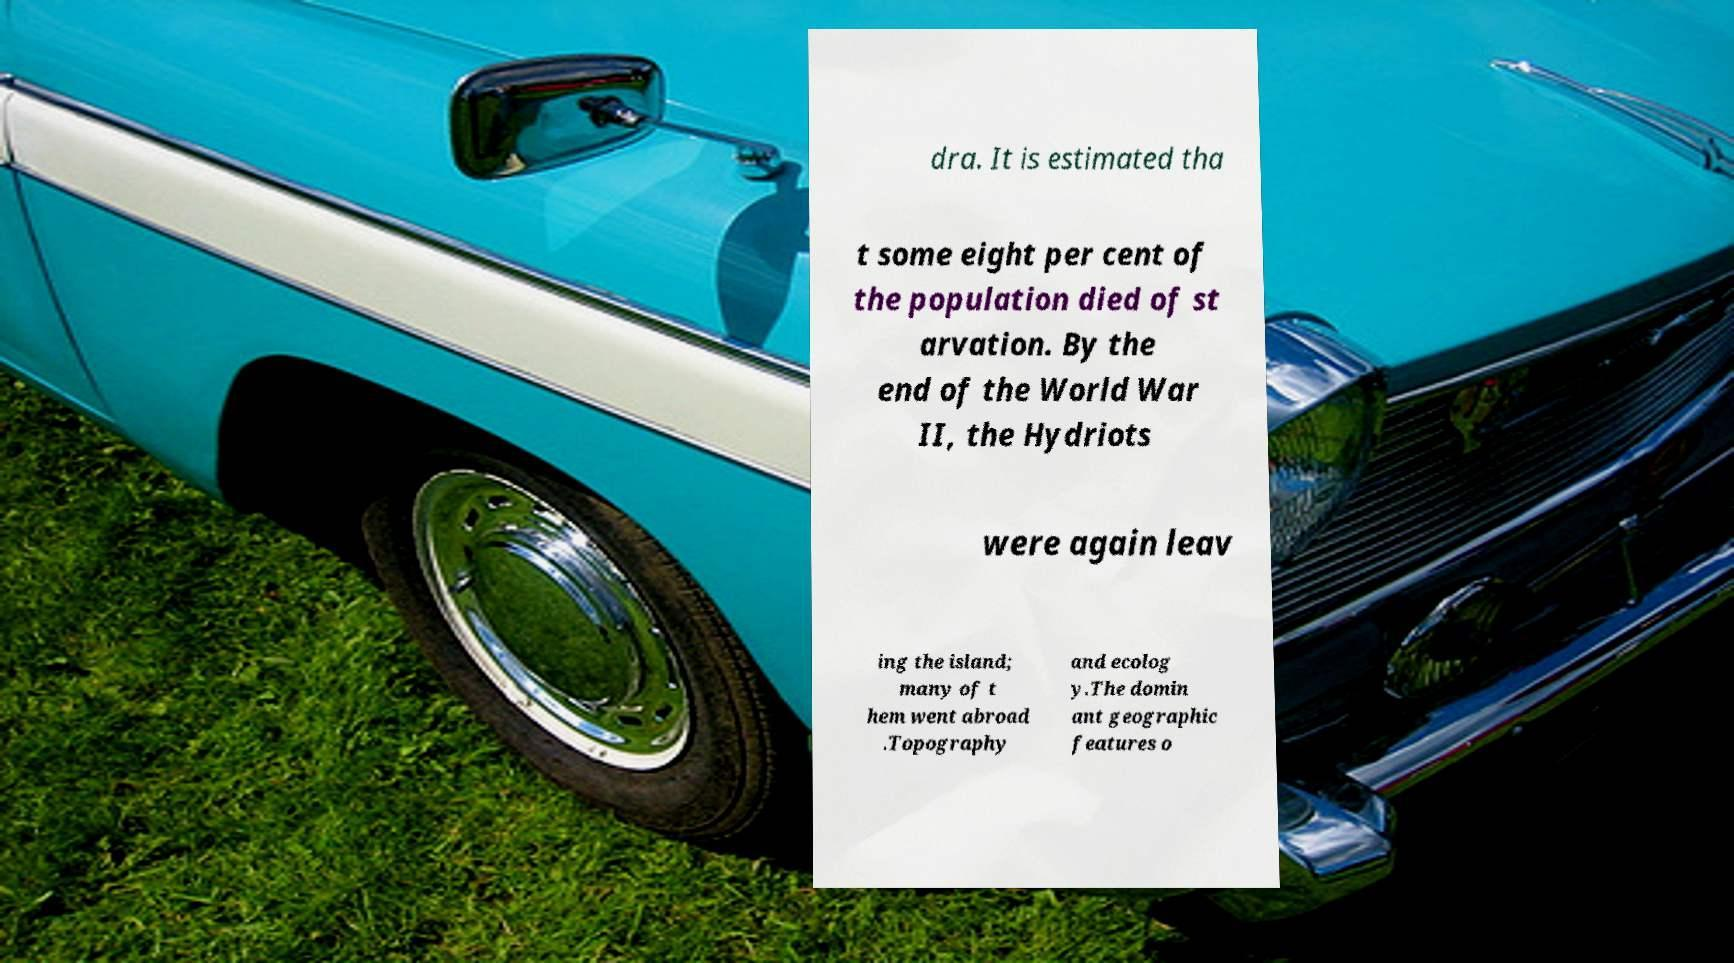Could you extract and type out the text from this image? dra. It is estimated tha t some eight per cent of the population died of st arvation. By the end of the World War II, the Hydriots were again leav ing the island; many of t hem went abroad .Topography and ecolog y.The domin ant geographic features o 